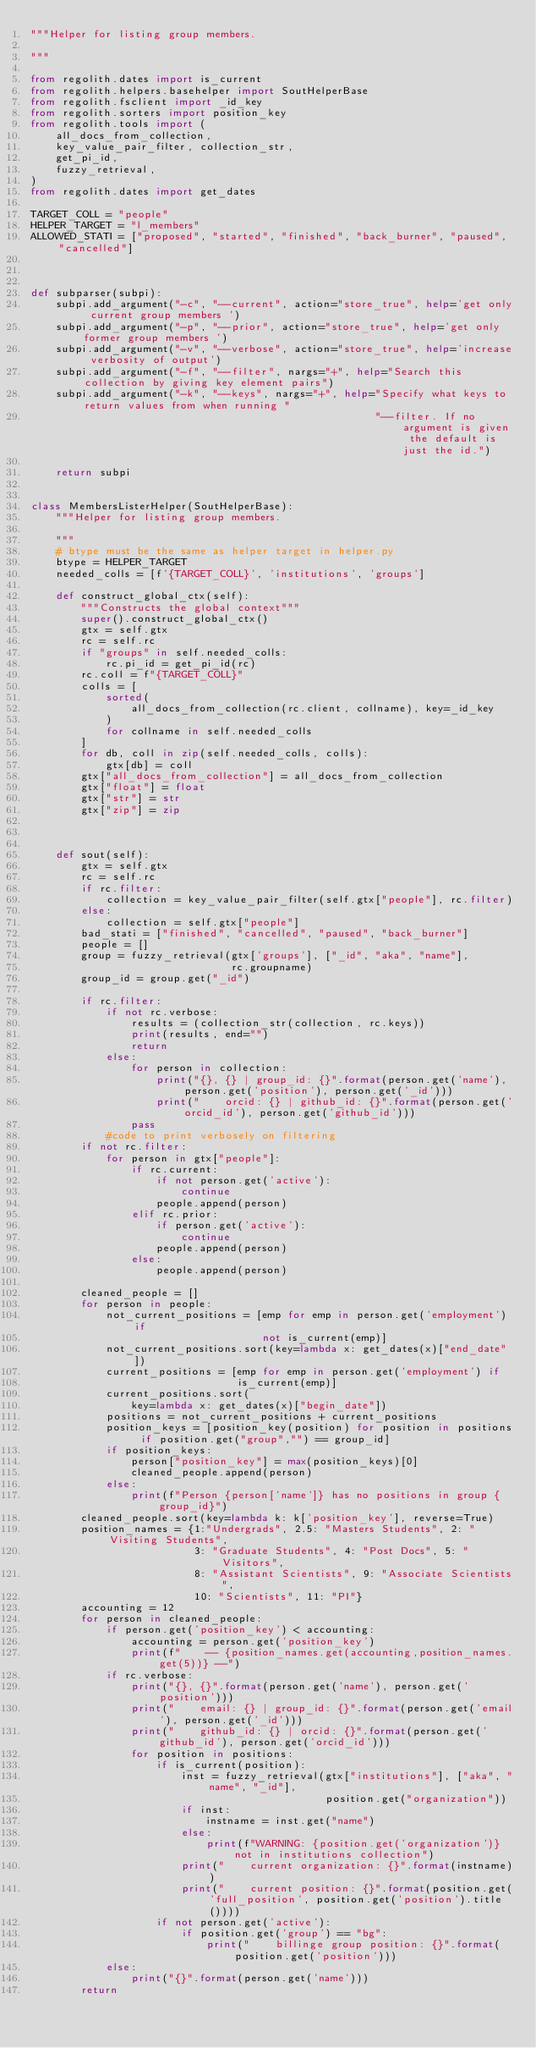Convert code to text. <code><loc_0><loc_0><loc_500><loc_500><_Python_>"""Helper for listing group members.

"""

from regolith.dates import is_current
from regolith.helpers.basehelper import SoutHelperBase
from regolith.fsclient import _id_key
from regolith.sorters import position_key
from regolith.tools import (
    all_docs_from_collection,
    key_value_pair_filter, collection_str,
    get_pi_id,
    fuzzy_retrieval,
)
from regolith.dates import get_dates

TARGET_COLL = "people"
HELPER_TARGET = "l_members"
ALLOWED_STATI = ["proposed", "started", "finished", "back_burner", "paused", "cancelled"]



def subparser(subpi):
    subpi.add_argument("-c", "--current", action="store_true", help='get only current group members ')
    subpi.add_argument("-p", "--prior", action="store_true", help='get only former group members ')
    subpi.add_argument("-v", "--verbose", action="store_true", help='increase verbosity of output')
    subpi.add_argument("-f", "--filter", nargs="+", help="Search this collection by giving key element pairs")
    subpi.add_argument("-k", "--keys", nargs="+", help="Specify what keys to return values from when running "
                                                       "--filter. If no argument is given the default is just the id.")

    return subpi


class MembersListerHelper(SoutHelperBase):
    """Helper for listing group members.

    """
    # btype must be the same as helper target in helper.py
    btype = HELPER_TARGET
    needed_colls = [f'{TARGET_COLL}', 'institutions', 'groups']

    def construct_global_ctx(self):
        """Constructs the global context"""
        super().construct_global_ctx()
        gtx = self.gtx
        rc = self.rc
        if "groups" in self.needed_colls:
            rc.pi_id = get_pi_id(rc)
        rc.coll = f"{TARGET_COLL}"
        colls = [
            sorted(
                all_docs_from_collection(rc.client, collname), key=_id_key
            )
            for collname in self.needed_colls
        ]
        for db, coll in zip(self.needed_colls, colls):
            gtx[db] = coll
        gtx["all_docs_from_collection"] = all_docs_from_collection
        gtx["float"] = float
        gtx["str"] = str
        gtx["zip"] = zip



    def sout(self):
        gtx = self.gtx
        rc = self.rc
        if rc.filter:
            collection = key_value_pair_filter(self.gtx["people"], rc.filter)
        else:
            collection = self.gtx["people"]
        bad_stati = ["finished", "cancelled", "paused", "back_burner"]
        people = []
        group = fuzzy_retrieval(gtx['groups'], ["_id", "aka", "name"],
                                rc.groupname)
        group_id = group.get("_id")

        if rc.filter:
            if not rc.verbose:
                results = (collection_str(collection, rc.keys))
                print(results, end="")
                return
            else:
                for person in collection:
                    print("{}, {} | group_id: {}".format(person.get('name'), person.get('position'), person.get('_id')))
                    print("    orcid: {} | github_id: {}".format(person.get('orcid_id'), person.get('github_id')))
                pass
            #code to print verbosely on filtering
        if not rc.filter:
            for person in gtx["people"]:
                if rc.current:
                    if not person.get('active'):
                        continue
                    people.append(person)
                elif rc.prior:
                    if person.get('active'):
                        continue
                    people.append(person)
                else:
                    people.append(person)

        cleaned_people = []
        for person in people:
            not_current_positions = [emp for emp in person.get('employment') if
                                     not is_current(emp)]
            not_current_positions.sort(key=lambda x: get_dates(x)["end_date"])
            current_positions = [emp for emp in person.get('employment') if
                                 is_current(emp)]
            current_positions.sort(
                key=lambda x: get_dates(x)["begin_date"])
            positions = not_current_positions + current_positions
            position_keys = [position_key(position) for position in positions if position.get("group","") == group_id]
            if position_keys:
                person["position_key"] = max(position_keys)[0]
                cleaned_people.append(person)
            else:
                print(f"Person {person['name']} has no positions in group {group_id}")
        cleaned_people.sort(key=lambda k: k['position_key'], reverse=True)
        position_names = {1:"Undergrads", 2.5: "Masters Students", 2: "Visiting Students",
                          3: "Graduate Students", 4: "Post Docs", 5: "Visitors",
                          8: "Assistant Scientists", 9: "Associate Scientists",
                          10: "Scientists", 11: "PI"}
        accounting = 12
        for person in cleaned_people:
            if person.get('position_key') < accounting:
                accounting = person.get('position_key')
                print(f"    -- {position_names.get(accounting,position_names.get(5))} --")
            if rc.verbose:
                print("{}, {}".format(person.get('name'), person.get('position')))
                print("    email: {} | group_id: {}".format(person.get('email'), person.get('_id')))
                print("    github_id: {} | orcid: {}".format(person.get('github_id'), person.get('orcid_id')))
                for position in positions:
                    if is_current(position):
                        inst = fuzzy_retrieval(gtx["institutions"], ["aka", "name", "_id"],
                                               position.get("organization"))
                        if inst:
                            instname = inst.get("name")
                        else:
                            print(f"WARNING: {position.get('organization')} not in institutions collection")
                        print("    current organization: {}".format(instname))
                        print("    current position: {}".format(position.get('full_position', position.get('position').title())))
                    if not person.get('active'):
                        if position.get('group') == "bg":
                            print("    billinge group position: {}".format(position.get('position')))
            else:
                print("{}".format(person.get('name')))
        return
</code> 